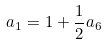<formula> <loc_0><loc_0><loc_500><loc_500>a _ { 1 } = 1 + \frac { 1 } { 2 } a _ { 6 }</formula> 